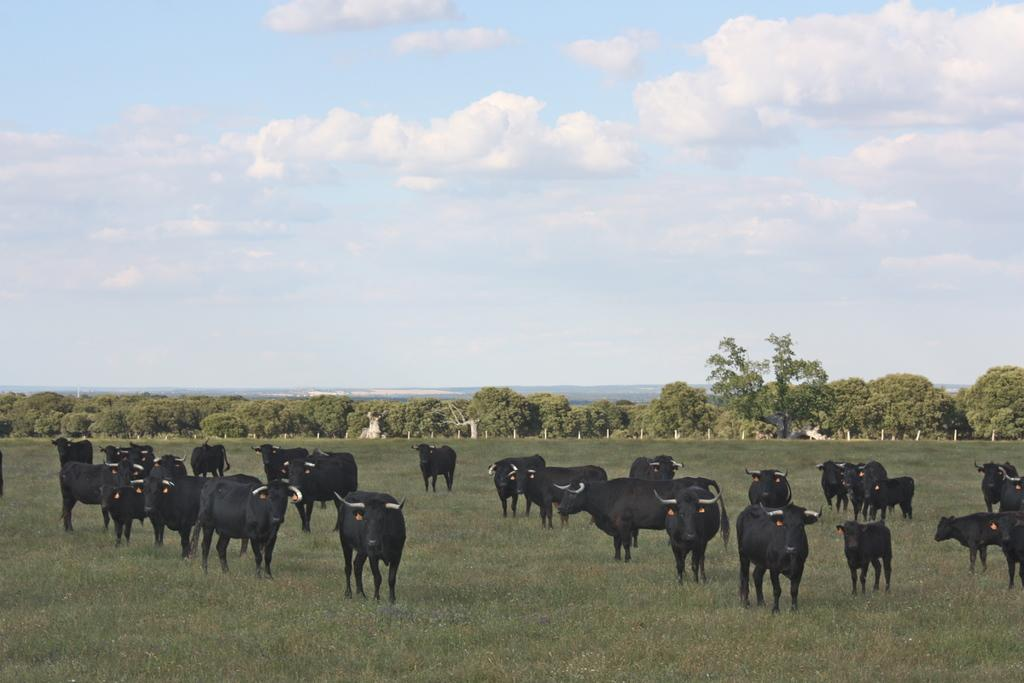What color are the oxen in the image? The oxen in the image are black. What are the oxen doing in the image? The oxen are standing in the image. What type of vegetation is at the bottom of the image? There is grass at the bottom of the image. What can be seen in the background of the image? There are trees in the background of the image. What is visible at the top of the image? The sky is visible at the top of the image. What type of texture can be seen on the school building in the image? There is no school building present in the image; it features black oxen standing in a grassy area with trees in the background and the sky visible at the top. 